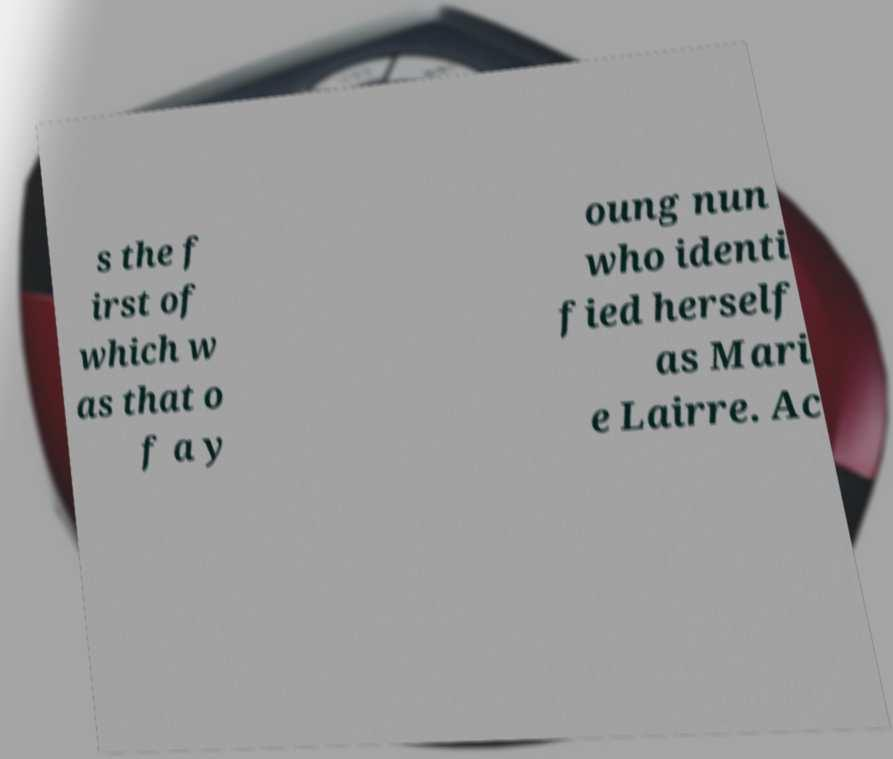Please identify and transcribe the text found in this image. s the f irst of which w as that o f a y oung nun who identi fied herself as Mari e Lairre. Ac 